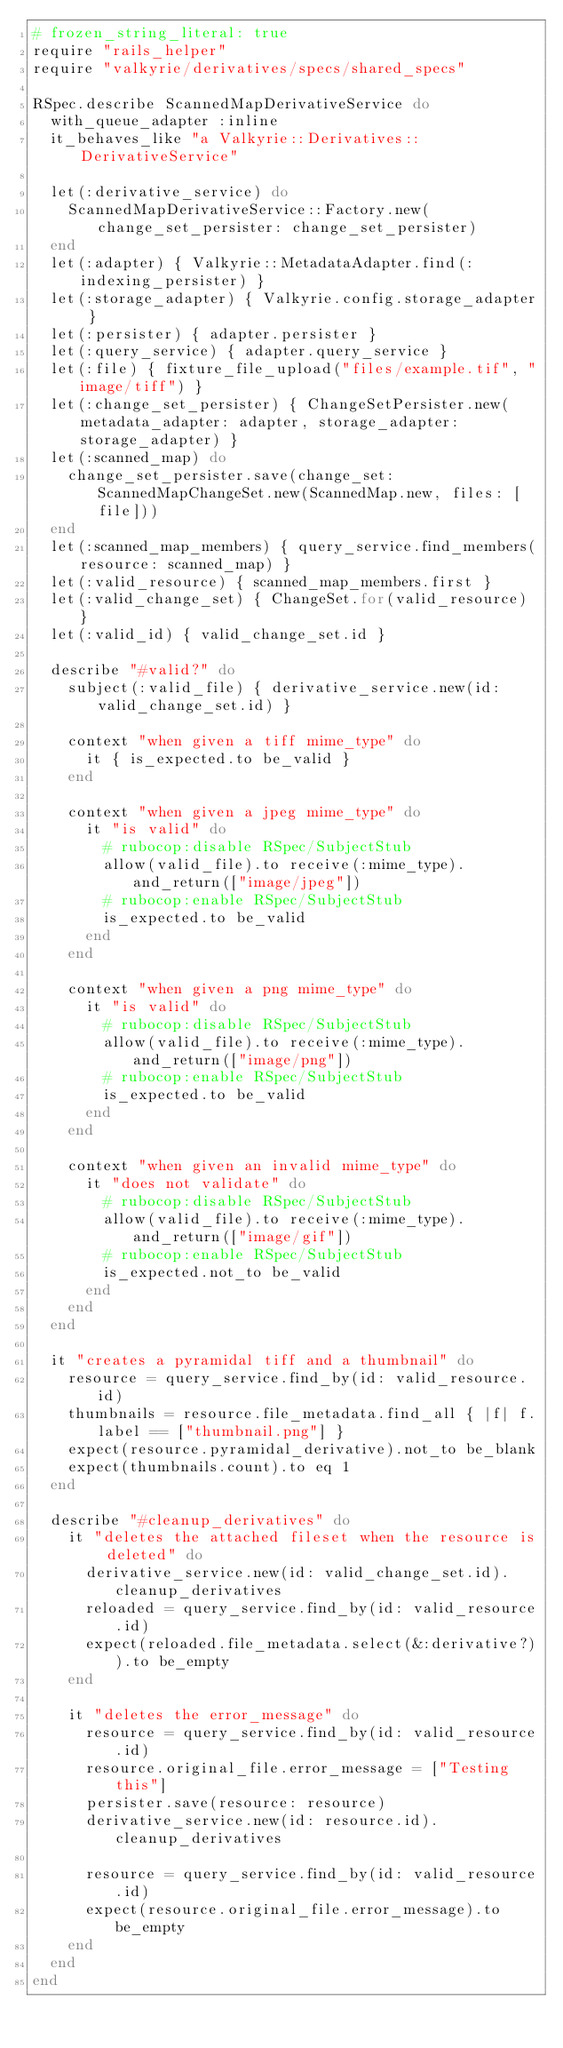<code> <loc_0><loc_0><loc_500><loc_500><_Ruby_># frozen_string_literal: true
require "rails_helper"
require "valkyrie/derivatives/specs/shared_specs"

RSpec.describe ScannedMapDerivativeService do
  with_queue_adapter :inline
  it_behaves_like "a Valkyrie::Derivatives::DerivativeService"

  let(:derivative_service) do
    ScannedMapDerivativeService::Factory.new(change_set_persister: change_set_persister)
  end
  let(:adapter) { Valkyrie::MetadataAdapter.find(:indexing_persister) }
  let(:storage_adapter) { Valkyrie.config.storage_adapter }
  let(:persister) { adapter.persister }
  let(:query_service) { adapter.query_service }
  let(:file) { fixture_file_upload("files/example.tif", "image/tiff") }
  let(:change_set_persister) { ChangeSetPersister.new(metadata_adapter: adapter, storage_adapter: storage_adapter) }
  let(:scanned_map) do
    change_set_persister.save(change_set: ScannedMapChangeSet.new(ScannedMap.new, files: [file]))
  end
  let(:scanned_map_members) { query_service.find_members(resource: scanned_map) }
  let(:valid_resource) { scanned_map_members.first }
  let(:valid_change_set) { ChangeSet.for(valid_resource) }
  let(:valid_id) { valid_change_set.id }

  describe "#valid?" do
    subject(:valid_file) { derivative_service.new(id: valid_change_set.id) }

    context "when given a tiff mime_type" do
      it { is_expected.to be_valid }
    end

    context "when given a jpeg mime_type" do
      it "is valid" do
        # rubocop:disable RSpec/SubjectStub
        allow(valid_file).to receive(:mime_type).and_return(["image/jpeg"])
        # rubocop:enable RSpec/SubjectStub
        is_expected.to be_valid
      end
    end

    context "when given a png mime_type" do
      it "is valid" do
        # rubocop:disable RSpec/SubjectStub
        allow(valid_file).to receive(:mime_type).and_return(["image/png"])
        # rubocop:enable RSpec/SubjectStub
        is_expected.to be_valid
      end
    end

    context "when given an invalid mime_type" do
      it "does not validate" do
        # rubocop:disable RSpec/SubjectStub
        allow(valid_file).to receive(:mime_type).and_return(["image/gif"])
        # rubocop:enable RSpec/SubjectStub
        is_expected.not_to be_valid
      end
    end
  end

  it "creates a pyramidal tiff and a thumbnail" do
    resource = query_service.find_by(id: valid_resource.id)
    thumbnails = resource.file_metadata.find_all { |f| f.label == ["thumbnail.png"] }
    expect(resource.pyramidal_derivative).not_to be_blank
    expect(thumbnails.count).to eq 1
  end

  describe "#cleanup_derivatives" do
    it "deletes the attached fileset when the resource is deleted" do
      derivative_service.new(id: valid_change_set.id).cleanup_derivatives
      reloaded = query_service.find_by(id: valid_resource.id)
      expect(reloaded.file_metadata.select(&:derivative?)).to be_empty
    end

    it "deletes the error_message" do
      resource = query_service.find_by(id: valid_resource.id)
      resource.original_file.error_message = ["Testing this"]
      persister.save(resource: resource)
      derivative_service.new(id: resource.id).cleanup_derivatives

      resource = query_service.find_by(id: valid_resource.id)
      expect(resource.original_file.error_message).to be_empty
    end
  end
end
</code> 